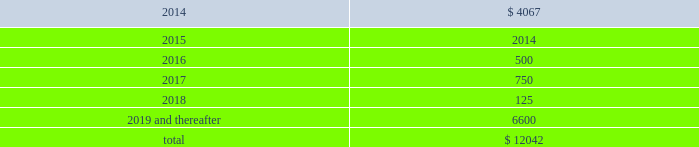Devon energy corporation and subsidiaries notes to consolidated financial statements 2013 ( continued ) debt maturities as of december 31 , 2013 , excluding premiums and discounts , are as follows ( in millions ) : .
Credit lines devon has a $ 3.0 billion syndicated , unsecured revolving line of credit ( the 201csenior credit facility 201d ) that matures on october 24 , 2018 .
However , prior to the maturity date , devon has the option to extend the maturity for up to one additional one-year period , subject to the approval of the lenders .
Amounts borrowed under the senior credit facility may , at the election of devon , bear interest at various fixed rate options for periods of up to twelve months .
Such rates are generally less than the prime rate .
However , devon may elect to borrow at the prime rate .
The senior credit facility currently provides for an annual facility fee of $ 3.8 million that is payable quarterly in arrears .
As of december 31 , 2013 , there were no borrowings under the senior credit facility .
The senior credit facility contains only one material financial covenant .
This covenant requires devon 2019s ratio of total funded debt to total capitalization , as defined in the credit agreement , to be no greater than 65 percent .
The credit agreement contains definitions of total funded debt and total capitalization that include adjustments to the respective amounts reported in the accompanying financial statements .
Also , total capitalization is adjusted to add back noncash financial write-downs such as full cost ceiling impairments or goodwill impairments .
As of december 31 , 2013 , devon was in compliance with this covenant with a debt-to- capitalization ratio of 25.7 percent .
Commercial paper devon has access to $ 3.0 billion of short-term credit under its commercial paper program .
Commercial paper debt generally has a maturity of between 1 and 90 days , although it can have a maturity of up to 365 days , and bears interest at rates agreed to at the time of the borrowing .
The interest rate is generally based on a standard index such as the federal funds rate , libor , or the money market rate as found in the commercial paper market .
As of december 31 , 2013 , devon 2019s weighted average borrowing rate on its commercial paper borrowings was 0.30 percent .
Other debentures and notes following are descriptions of the various other debentures and notes outstanding at december 31 , 2013 , as listed in the table presented at the beginning of this note .
Geosouthern debt in december 2013 , in conjunction with the planned geosouthern acquisition , devon issued $ 2.25 billion aggregate principal amount of fixed and floating rate senior notes resulting in cash proceeds of approximately .
Based on the december 31 , 2013 , devon 2019s weighted average borrowing rate on its commercial paper borrowings what was the potential value of its commercial paper asset in billions? 
Computations: (3 * 0.30)
Answer: 0.9. 